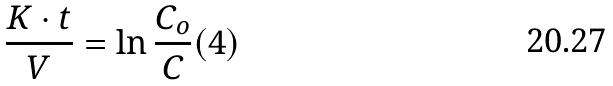Convert formula to latex. <formula><loc_0><loc_0><loc_500><loc_500>\frac { K \cdot t } { V } = \ln \frac { C _ { o } } { C } ( 4 )</formula> 